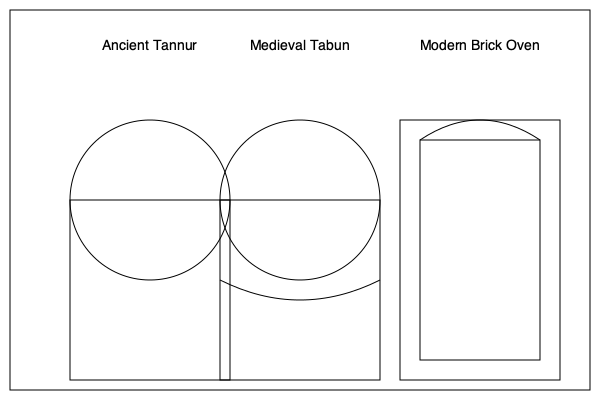Analyze the architectural evolution of traditional Middle Eastern bread ovens as depicted in the cross-sectional diagrams. What key structural changes occurred from the ancient tannur to the modern brick oven, and how did these modifications impact bread-making techniques and efficiency? 1. Ancient Tannur:
   - Cylindrical structure with an open top
   - Simple design with a single chamber
   - Heat distribution relies on radiant heat from walls

2. Medieval Tabun:
   - Retained cylindrical shape but added a domed top
   - Improved heat retention and distribution
   - Introduction of a curved bottom for easier ash removal

3. Modern Brick Oven:
   - Rectangular shape with a separate combustion chamber
   - Arched top for better heat circulation
   - Increased size for larger bread production

Evolution analysis:
a) Shape transformation: From circular to rectangular, allowing for more efficient space utilization and larger batches of bread.

b) Heat management: The addition of the domed top in the tabun and the arched design in the brick oven improved heat circulation and retention, leading to more consistent baking temperatures.

c) Fuel efficiency: The separate combustion chamber in the modern brick oven allows for better control of heat and more efficient use of fuel.

d) Capacity: The gradual increase in size from tannur to brick oven enabled larger-scale bread production.

e) Baking technique adaptation: 
   - Tannur: Flatbreads stuck to walls
   - Tabun: Flatbreads on floor or walls
   - Brick oven: Various bread types on oven floor or in pans

Impact on bread-making:
1. Increased variety of bread types that could be produced
2. Improved consistency in baking results
3. Enhanced energy efficiency and temperature control
4. Ability to produce larger quantities of bread
5. Diversification of baking techniques (e.g., use of baking pans, multiple racks)

These architectural changes reflect the cultural and technological developments in Middle Eastern bread-making traditions, showcasing the adaptation of oven designs to meet evolving culinary needs and efficiency requirements.
Answer: Structural evolution from circular to rectangular shape, improved heat management through domed/arched tops, and increased size led to greater efficiency, capacity, and versatility in bread-making techniques. 